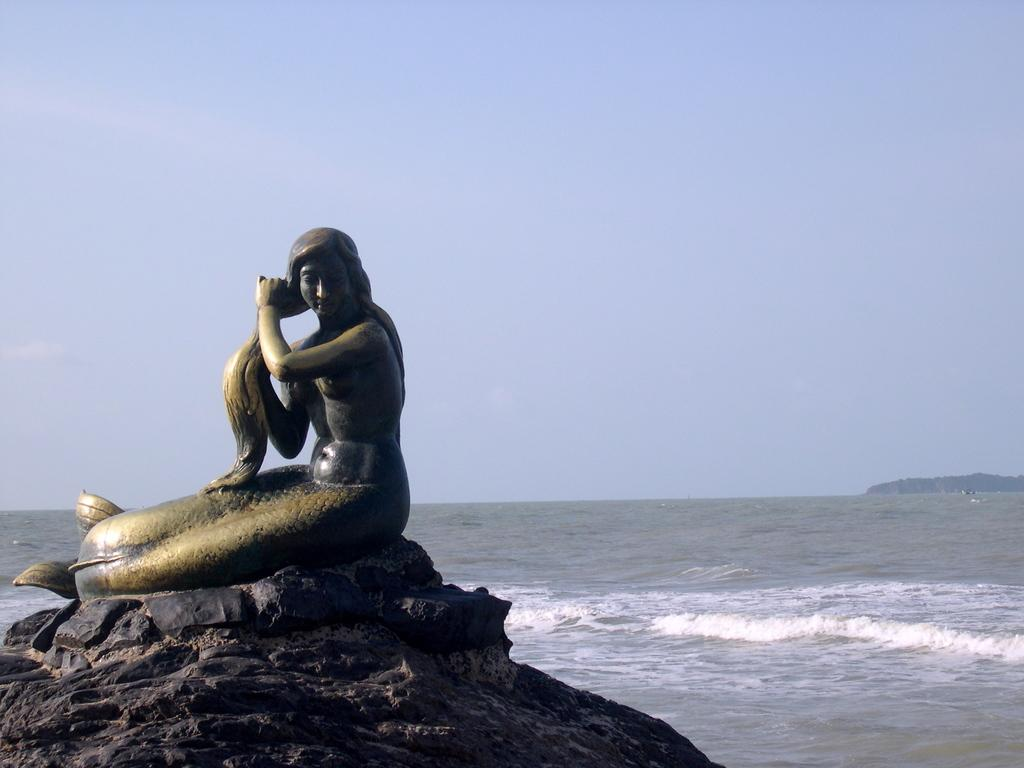What is the main subject in the foreground of the image? There is a sculpture on a rock in the foreground of the image. What natural feature can be seen in the background of the image? The background of the image includes the sea. What else is visible in the background of the image? The sky is visible in the background of the image. What type of control can be seen on the sculpture in the image? There is no control present on the sculpture in the image. How does the cork float in the sea in the image? There is no cork present in the image; it only features a sculpture on a rock, the sea, and the sky. 